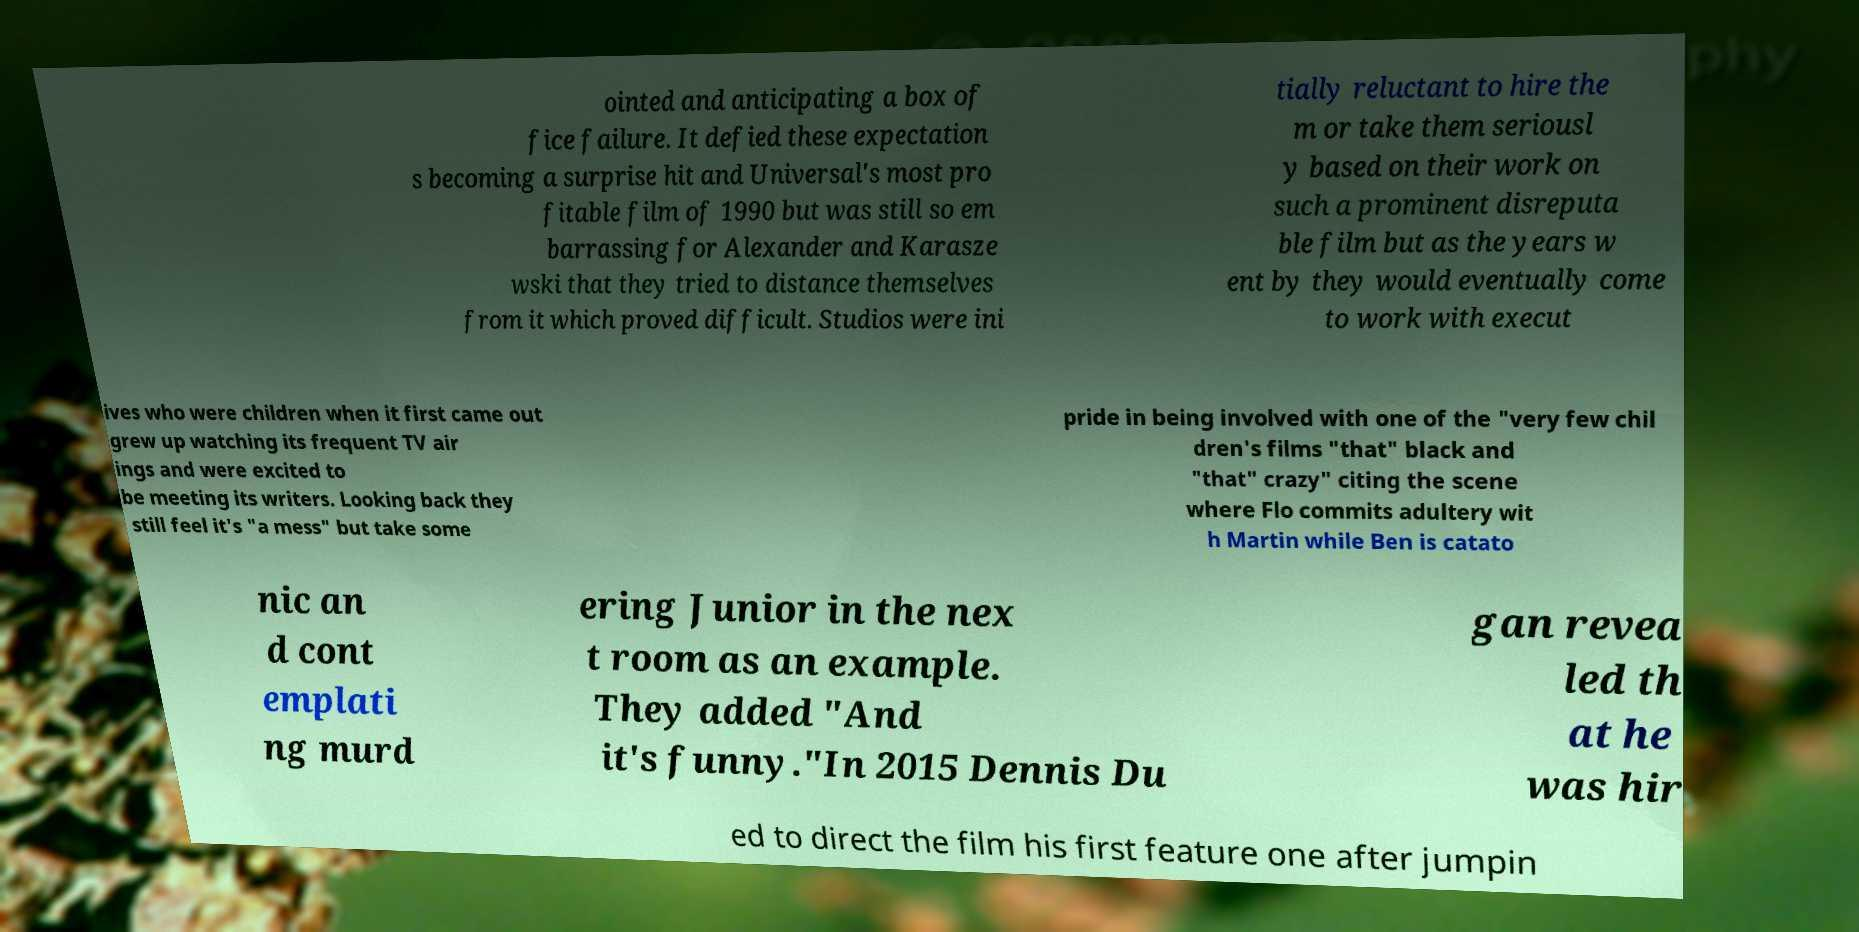Could you assist in decoding the text presented in this image and type it out clearly? ointed and anticipating a box of fice failure. It defied these expectation s becoming a surprise hit and Universal's most pro fitable film of 1990 but was still so em barrassing for Alexander and Karasze wski that they tried to distance themselves from it which proved difficult. Studios were ini tially reluctant to hire the m or take them seriousl y based on their work on such a prominent disreputa ble film but as the years w ent by they would eventually come to work with execut ives who were children when it first came out grew up watching its frequent TV air ings and were excited to be meeting its writers. Looking back they still feel it's "a mess" but take some pride in being involved with one of the "very few chil dren's films "that" black and "that" crazy" citing the scene where Flo commits adultery wit h Martin while Ben is catato nic an d cont emplati ng murd ering Junior in the nex t room as an example. They added "And it's funny."In 2015 Dennis Du gan revea led th at he was hir ed to direct the film his first feature one after jumpin 